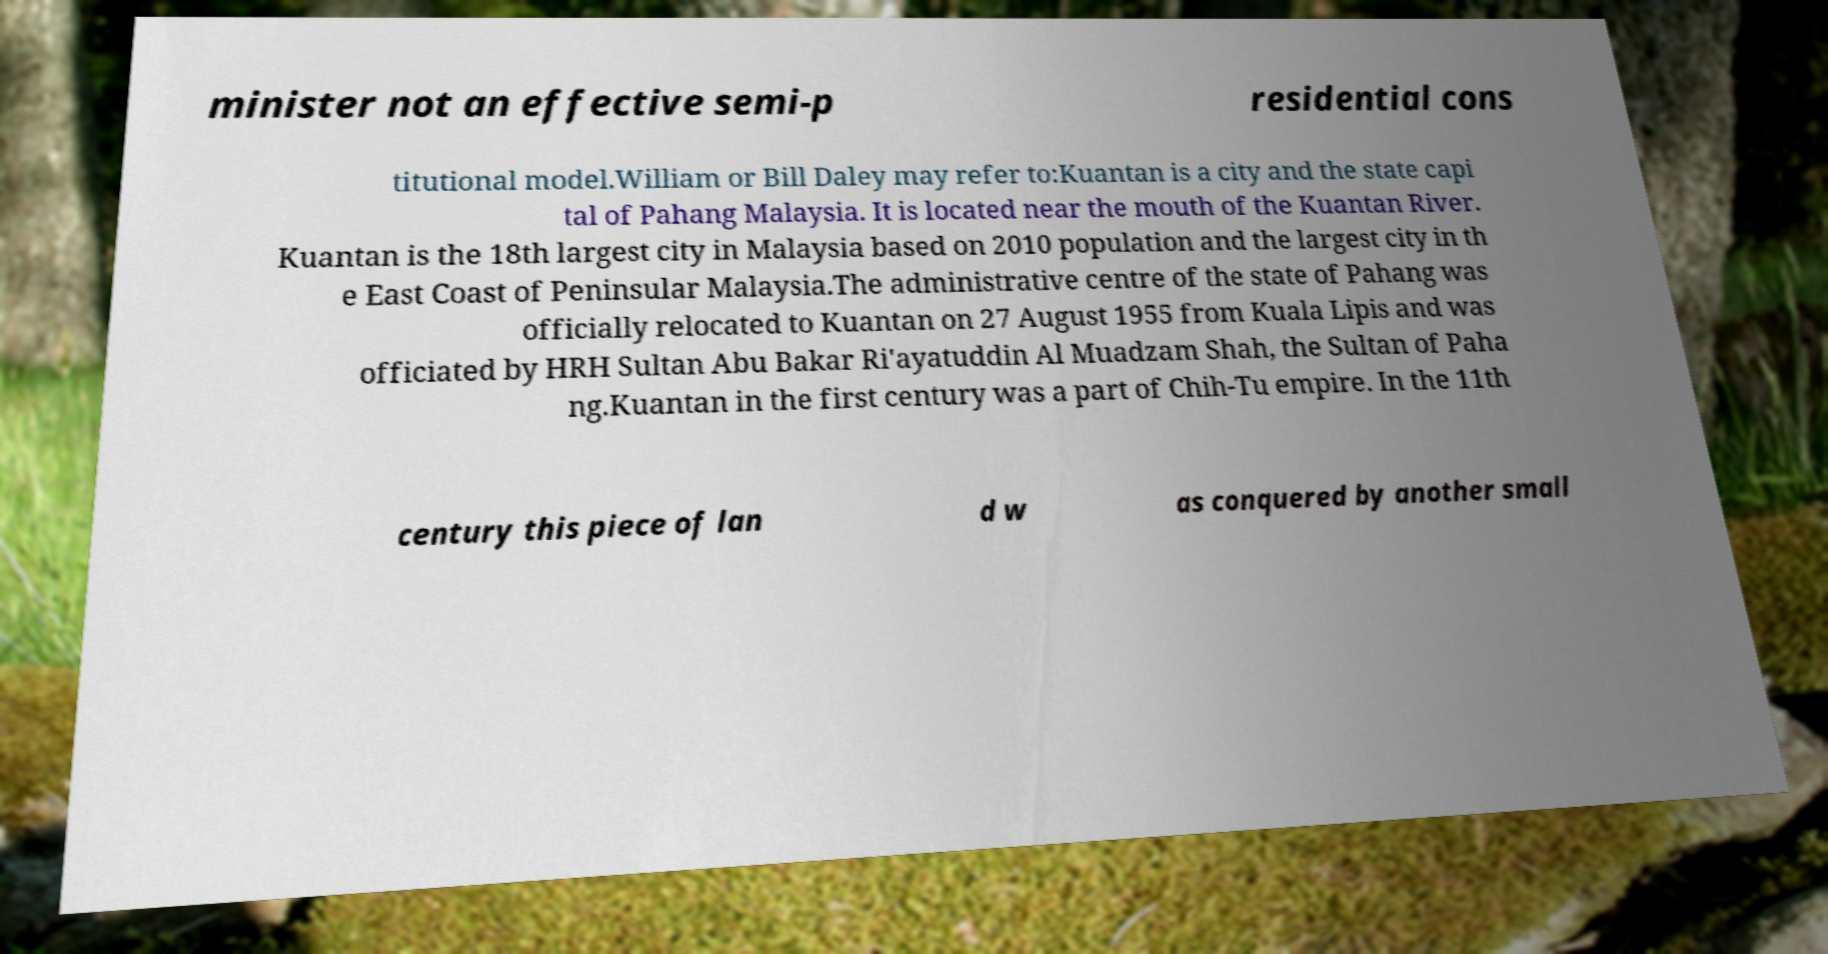Could you extract and type out the text from this image? minister not an effective semi-p residential cons titutional model.William or Bill Daley may refer to:Kuantan is a city and the state capi tal of Pahang Malaysia. It is located near the mouth of the Kuantan River. Kuantan is the 18th largest city in Malaysia based on 2010 population and the largest city in th e East Coast of Peninsular Malaysia.The administrative centre of the state of Pahang was officially relocated to Kuantan on 27 August 1955 from Kuala Lipis and was officiated by HRH Sultan Abu Bakar Ri'ayatuddin Al Muadzam Shah, the Sultan of Paha ng.Kuantan in the first century was a part of Chih-Tu empire. In the 11th century this piece of lan d w as conquered by another small 